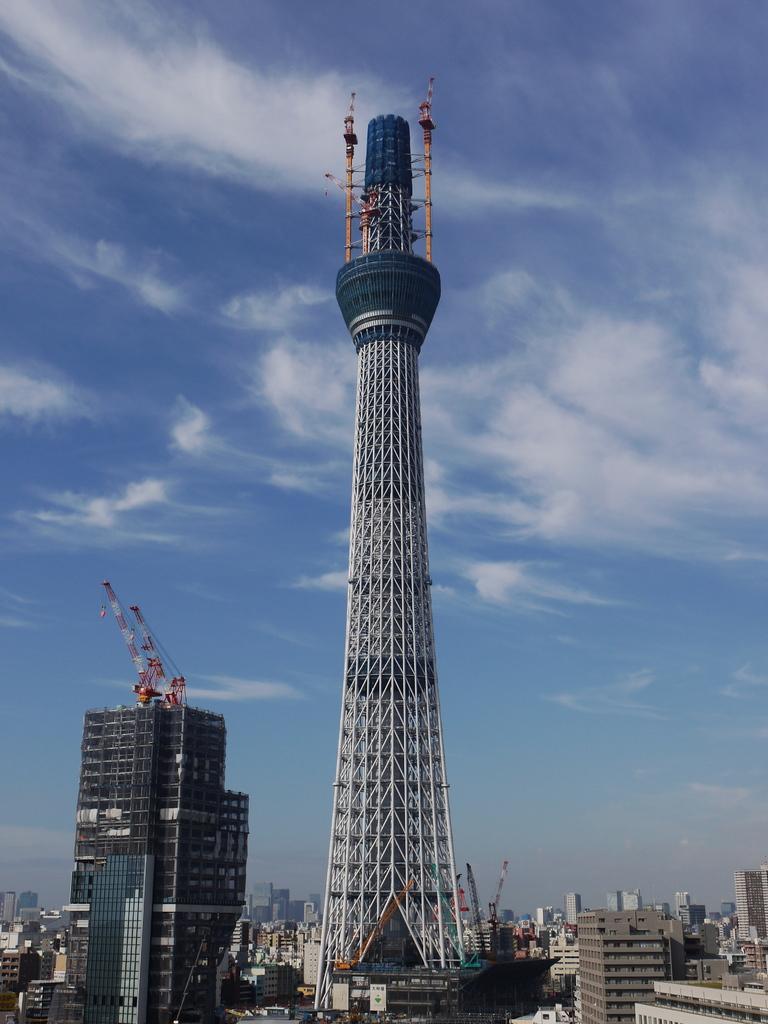Please provide a concise description of this image. In this image I can see number of buildings, a huge tower, few cranes which are red and white in color on the building. In the background I can see the sky. 